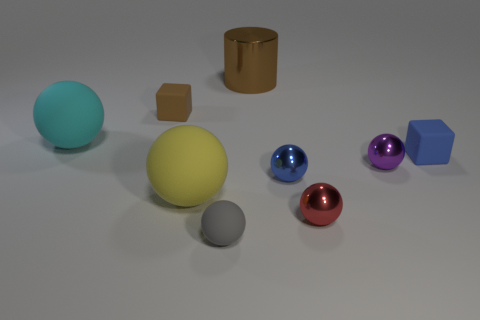What color is the rubber ball that is the same size as the purple object?
Provide a short and direct response. Gray. Is there a brown rubber block in front of the brown object on the left side of the small matte thing that is in front of the yellow matte thing?
Make the answer very short. No. There is a tiny cube that is to the right of the tiny gray rubber sphere; what material is it?
Provide a succinct answer. Rubber. There is a cyan thing; is it the same shape as the large matte thing in front of the blue matte cube?
Offer a terse response. Yes. Is the number of big things that are left of the big cyan sphere the same as the number of small brown things right of the blue sphere?
Your response must be concise. Yes. How many other objects are there of the same material as the cyan ball?
Give a very brief answer. 4. How many matte things are purple spheres or cyan spheres?
Make the answer very short. 1. Do the gray matte object in front of the tiny purple object and the yellow matte object have the same shape?
Make the answer very short. Yes. Are there more matte blocks to the left of the small gray sphere than large purple matte objects?
Your response must be concise. Yes. What number of matte things are to the right of the yellow ball and in front of the small blue block?
Provide a succinct answer. 1. 